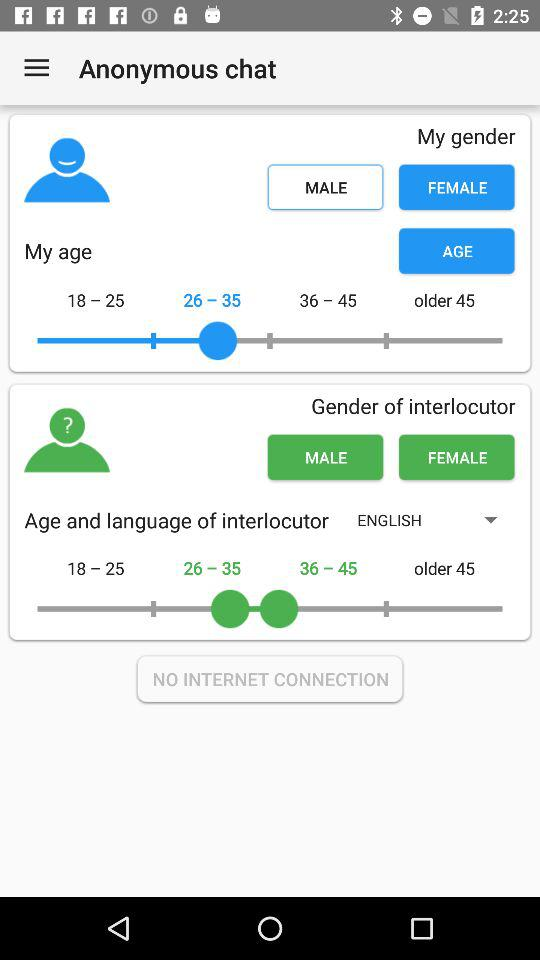What is the gender selected for My Age? The selected gender is female. 